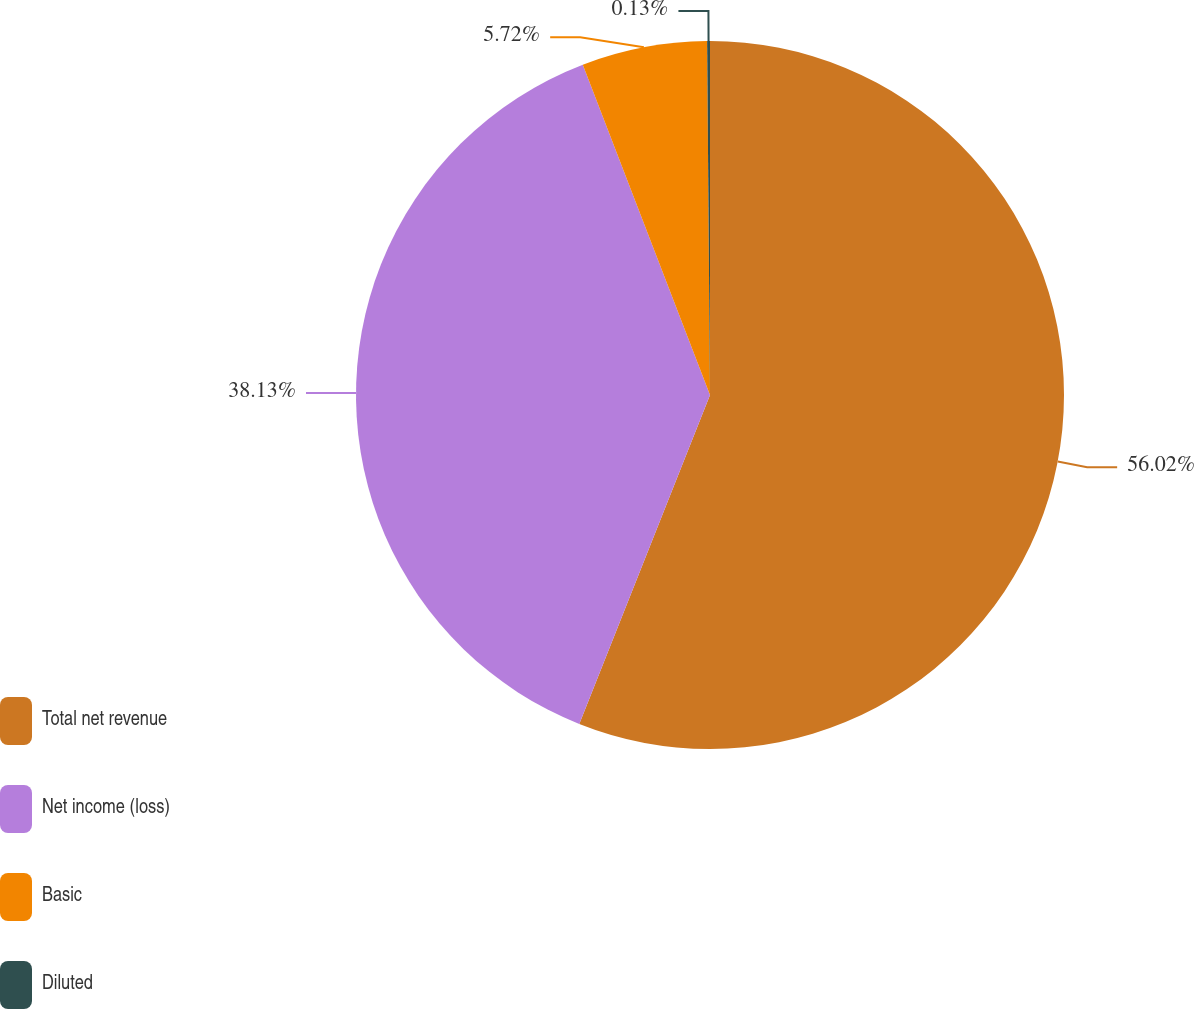Convert chart. <chart><loc_0><loc_0><loc_500><loc_500><pie_chart><fcel>Total net revenue<fcel>Net income (loss)<fcel>Basic<fcel>Diluted<nl><fcel>56.02%<fcel>38.13%<fcel>5.72%<fcel>0.13%<nl></chart> 